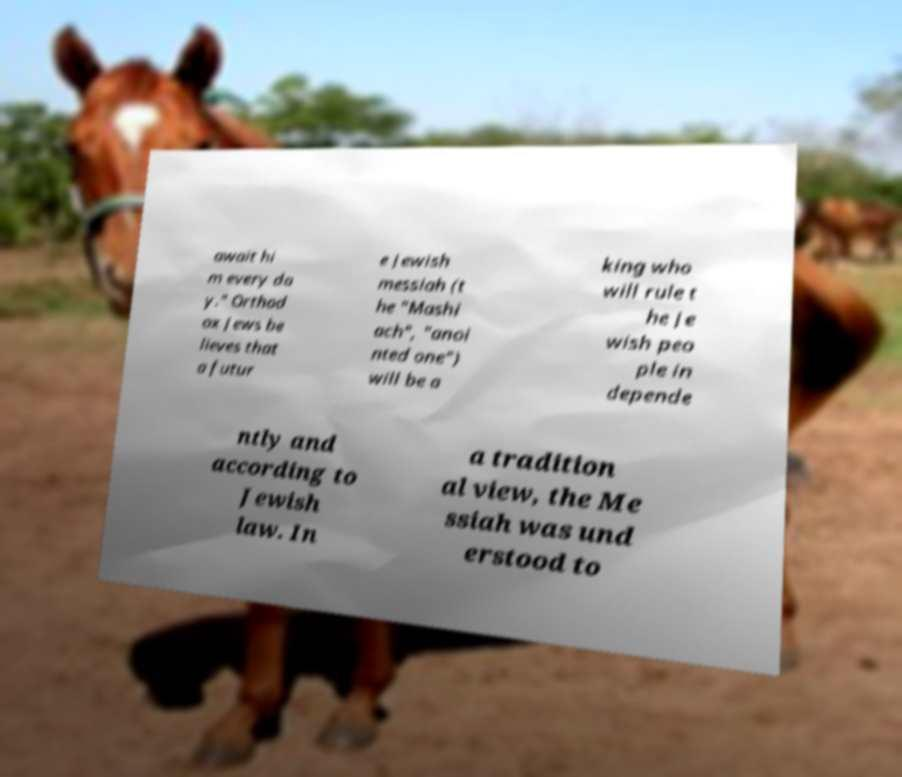For documentation purposes, I need the text within this image transcribed. Could you provide that? await hi m every da y." Orthod ox Jews be lieves that a futur e Jewish messiah (t he "Mashi ach", "anoi nted one") will be a king who will rule t he Je wish peo ple in depende ntly and according to Jewish law. In a tradition al view, the Me ssiah was und erstood to 